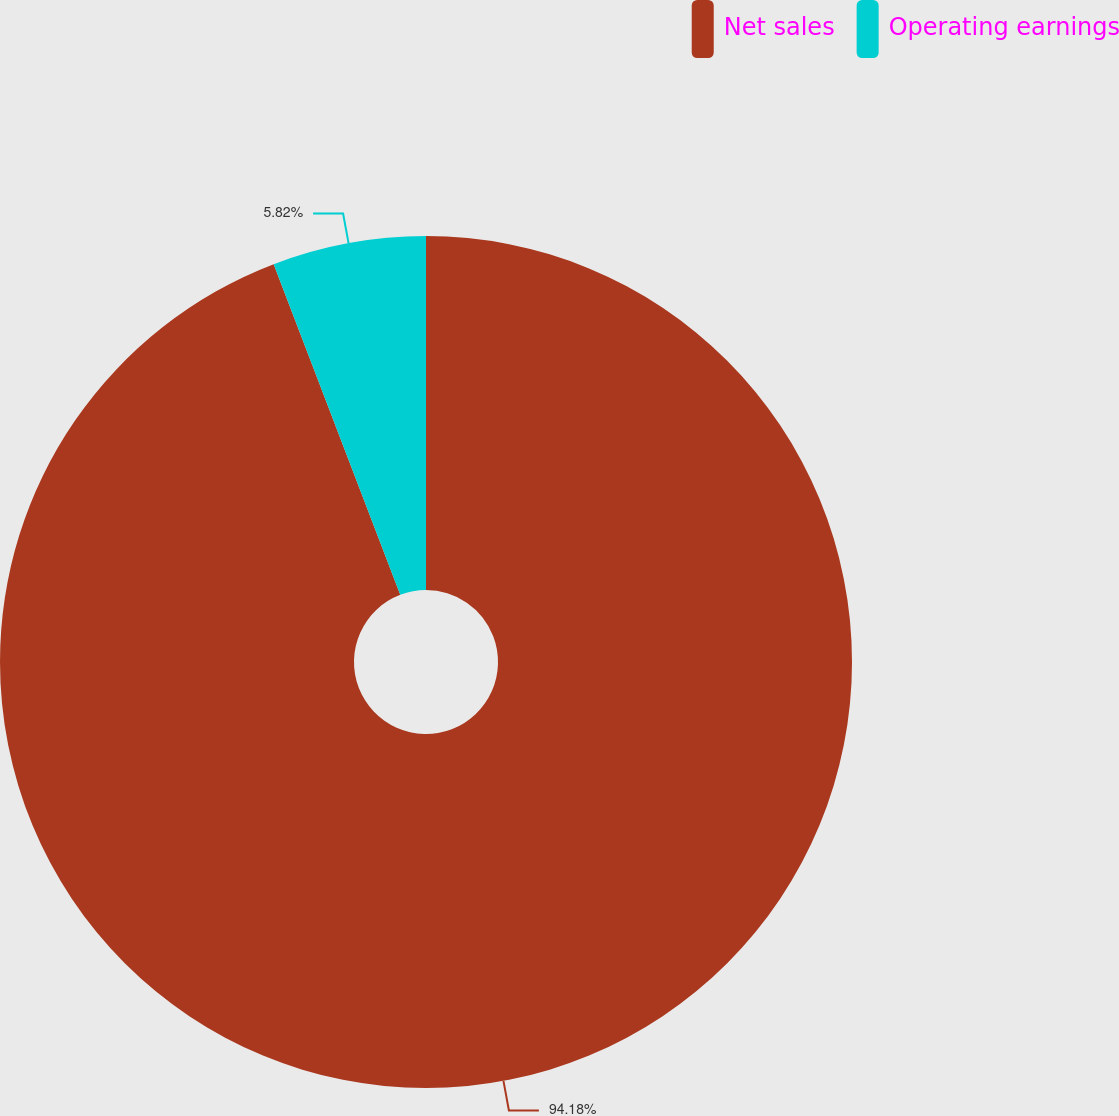Convert chart. <chart><loc_0><loc_0><loc_500><loc_500><pie_chart><fcel>Net sales<fcel>Operating earnings<nl><fcel>94.18%<fcel>5.82%<nl></chart> 